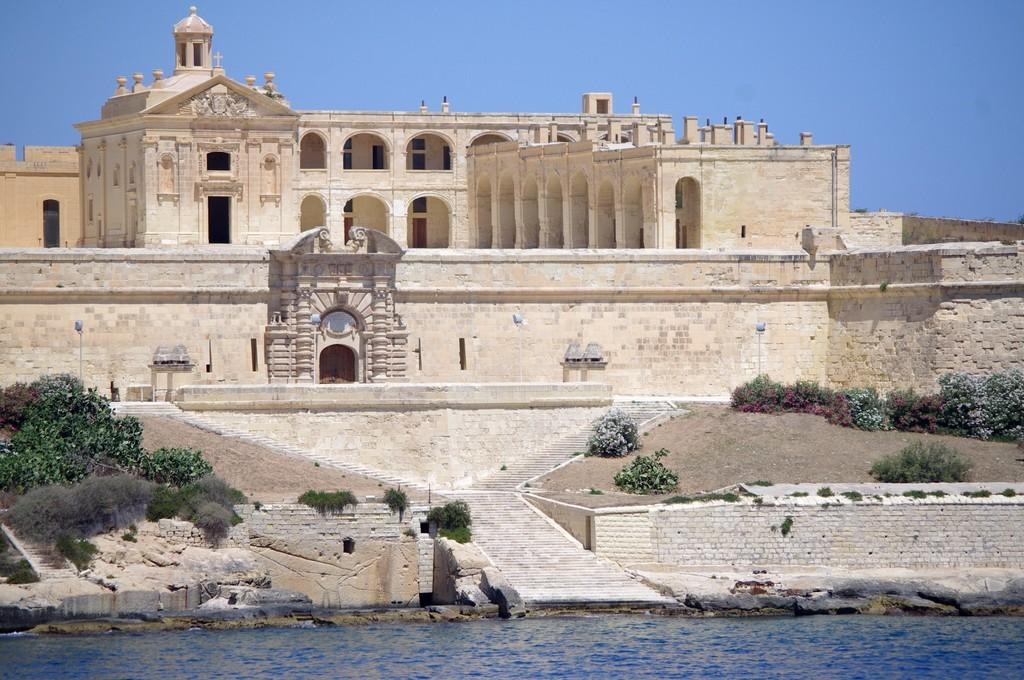What type of structure is featured in the image? There is a heritage building in the image. What other elements can be seen in the image besides the building? There are plants, water, stairs, and the sky visible in the image. Can you describe the plants in the image? The plants are not specifically described in the facts, but they are present in the image. What is the condition of the sky in the background of the image? The sky is visible in the background of the image. What is the: What type of tongue can be seen in the image? There is no tongue present in the image. 